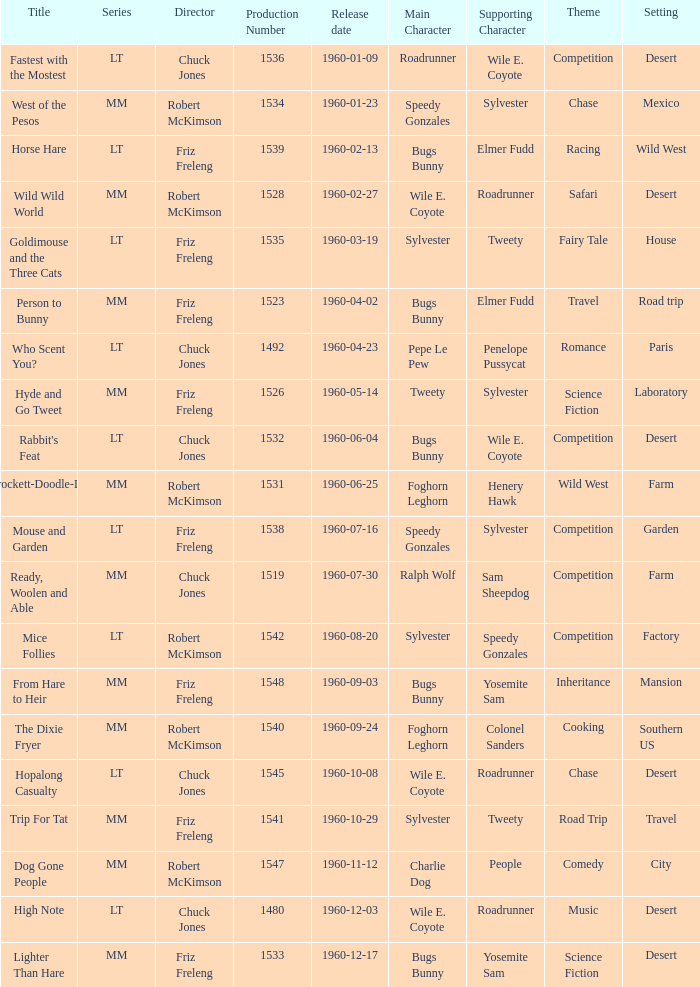What is the Series number of the episode with a production number of 1547? MM. Parse the table in full. {'header': ['Title', 'Series', 'Director', 'Production Number', 'Release date', 'Main Character', 'Supporting Character', 'Theme', 'Setting'], 'rows': [['Fastest with the Mostest', 'LT', 'Chuck Jones', '1536', '1960-01-09', 'Roadrunner', 'Wile E. Coyote', 'Competition', 'Desert'], ['West of the Pesos', 'MM', 'Robert McKimson', '1534', '1960-01-23', 'Speedy Gonzales', 'Sylvester', 'Chase', 'Mexico'], ['Horse Hare', 'LT', 'Friz Freleng', '1539', '1960-02-13', 'Bugs Bunny', 'Elmer Fudd', 'Racing', 'Wild West'], ['Wild Wild World', 'MM', 'Robert McKimson', '1528', '1960-02-27', 'Wile E. Coyote', 'Roadrunner', 'Safari', 'Desert'], ['Goldimouse and the Three Cats', 'LT', 'Friz Freleng', '1535', '1960-03-19', 'Sylvester', 'Tweety', 'Fairy Tale', 'House'], ['Person to Bunny', 'MM', 'Friz Freleng', '1523', '1960-04-02', 'Bugs Bunny', 'Elmer Fudd', 'Travel', 'Road trip'], ['Who Scent You?', 'LT', 'Chuck Jones', '1492', '1960-04-23', 'Pepe Le Pew', 'Penelope Pussycat', 'Romance', 'Paris'], ['Hyde and Go Tweet', 'MM', 'Friz Freleng', '1526', '1960-05-14', 'Tweety', 'Sylvester', 'Science Fiction', 'Laboratory'], ["Rabbit's Feat", 'LT', 'Chuck Jones', '1532', '1960-06-04', 'Bugs Bunny', 'Wile E. Coyote', 'Competition', 'Desert'], ['Crockett-Doodle-Do', 'MM', 'Robert McKimson', '1531', '1960-06-25', 'Foghorn Leghorn', 'Henery Hawk', 'Wild West', 'Farm'], ['Mouse and Garden', 'LT', 'Friz Freleng', '1538', '1960-07-16', 'Speedy Gonzales', 'Sylvester', 'Competition', 'Garden'], ['Ready, Woolen and Able', 'MM', 'Chuck Jones', '1519', '1960-07-30', 'Ralph Wolf', 'Sam Sheepdog', 'Competition', 'Farm'], ['Mice Follies', 'LT', 'Robert McKimson', '1542', '1960-08-20', 'Sylvester', 'Speedy Gonzales', 'Competition', 'Factory'], ['From Hare to Heir', 'MM', 'Friz Freleng', '1548', '1960-09-03', 'Bugs Bunny', 'Yosemite Sam', 'Inheritance', 'Mansion'], ['The Dixie Fryer', 'MM', 'Robert McKimson', '1540', '1960-09-24', 'Foghorn Leghorn', 'Colonel Sanders', 'Cooking', 'Southern US'], ['Hopalong Casualty', 'LT', 'Chuck Jones', '1545', '1960-10-08', 'Wile E. Coyote', 'Roadrunner', 'Chase', 'Desert'], ['Trip For Tat', 'MM', 'Friz Freleng', '1541', '1960-10-29', 'Sylvester', 'Tweety', 'Road Trip', 'Travel'], ['Dog Gone People', 'MM', 'Robert McKimson', '1547', '1960-11-12', 'Charlie Dog', 'People', 'Comedy', 'City'], ['High Note', 'LT', 'Chuck Jones', '1480', '1960-12-03', 'Wile E. Coyote', 'Roadrunner', 'Music', 'Desert'], ['Lighter Than Hare', 'MM', 'Friz Freleng', '1533', '1960-12-17', 'Bugs Bunny', 'Yosemite Sam', 'Science Fiction', 'Desert']]} 